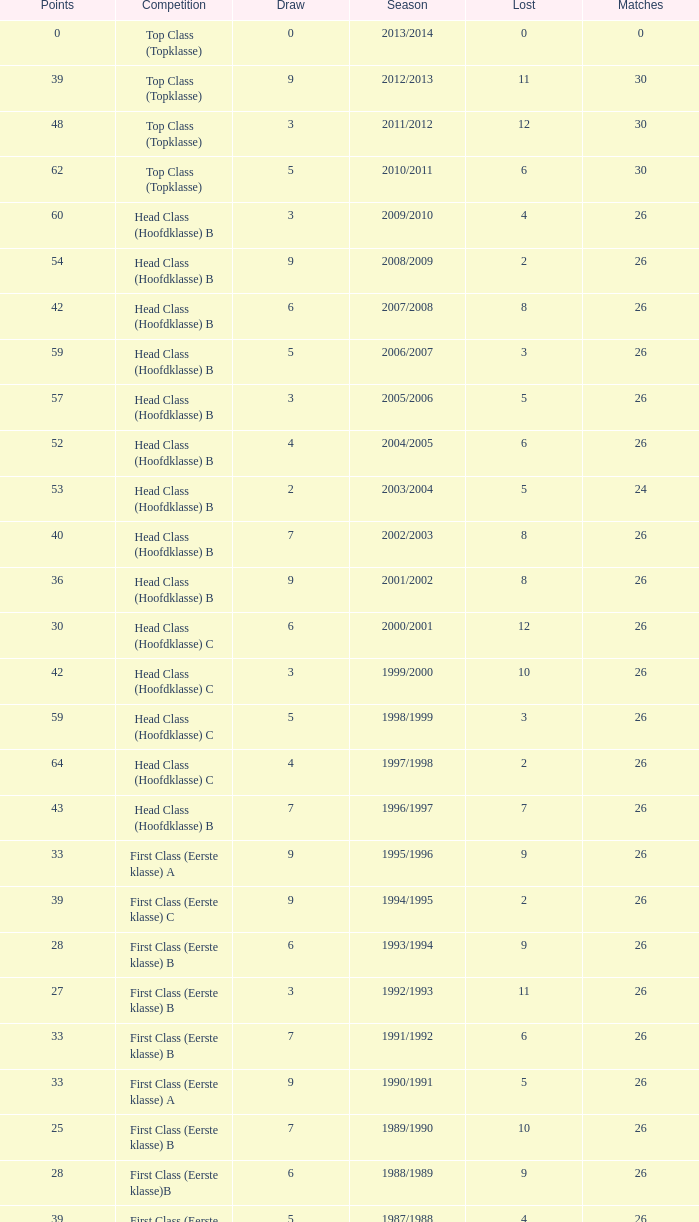What competition has a score greater than 30, a draw less than 5, and a loss larger than 10? Top Class (Topklasse). 